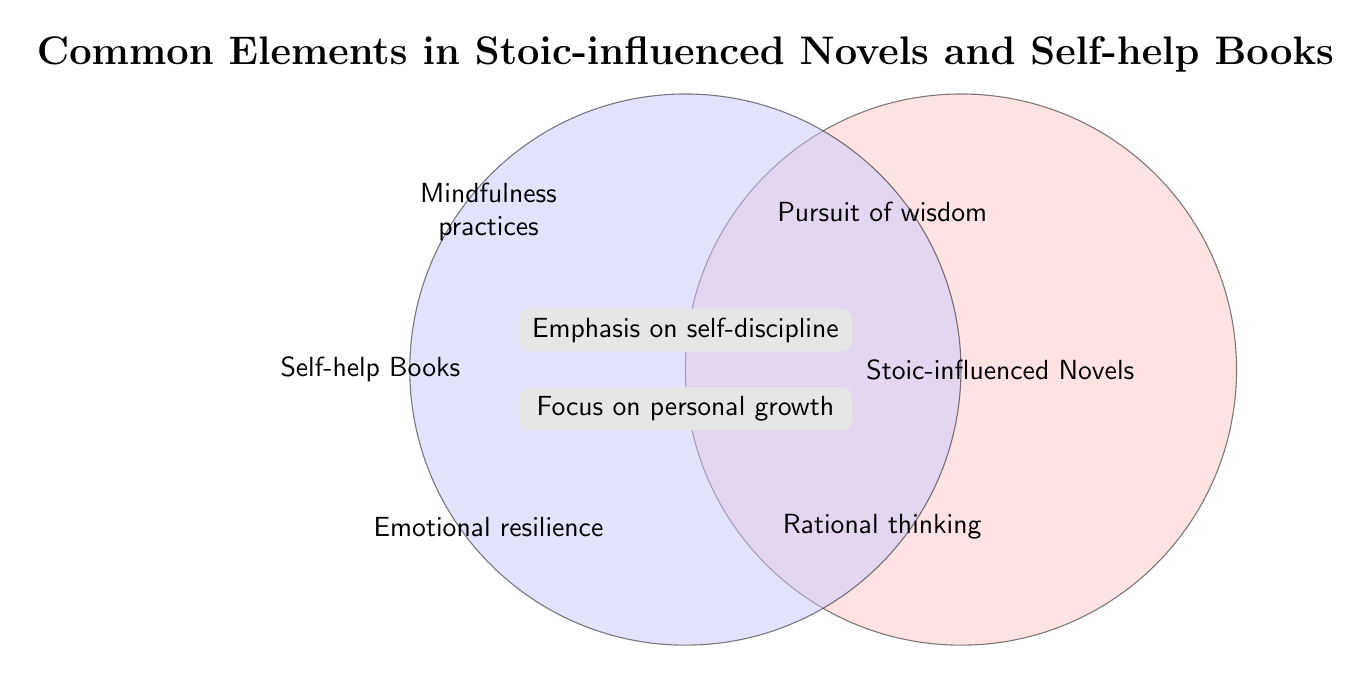What is the title of the Venn diagram? The title is written in the center at the top of the diagram. It reads "Common Elements in Stoic-influenced Novels and Self-help Books."
Answer: Common Elements in Stoic-influenced Novels and Self-help Books Which area represents Stoic-influenced novels? The area representing Stoic-influenced novels is the right circle, labeled "Stoic-influenced Novels."
Answer: Stoic-influenced Novels What are the elements unique to self-help books? The unique elements on the left side of the diagram are "Mindfulness practices" and "Emotional resilience."
Answer: Mindfulness practices, Emotional resilience Which elements are common between Stoic-influenced novels and self-help books? The elements found in the overlapping section of the two circles are "Emphasis on self-discipline" and "Focus on personal growth."
Answer: Emphasis on self-discipline, Focus on personal growth Can you name one Stoic-influenced novel and one self-help book that emphasize personal growth? "The Obstacle Is the Way" is a Stoic-influenced novel, while the self-help book is not specified but includes "Focus on personal growth" as a common element.
Answer: "The Obstacle Is the Way" (Stoic-influenced novel) Which area of the Venn diagram includes Rational thinking? The area for Rational thinking is in the Stoic-influenced Novels section, specifically on the right side.
Answer: Stoic-influenced Novels How many common elements are there between Stoic-influenced novels and self-help books? The diagram shows two common elements in the overlapping section: "Emphasis on self-discipline" and "Focus on personal growth."
Answer: Two Is "Pursuit of wisdom" a unique element or common between the two categories? "Pursuit of wisdom" is located in the Stoic-influenced Novels section and is unique to it, not common.
Answer: Unique Which focus area is common between the two types of books and emphasizes working on oneself over time? The common focus area that emphasizes ongoing personal development is "Focus on personal growth," found in both categories.
Answer: Focus on personal growth 